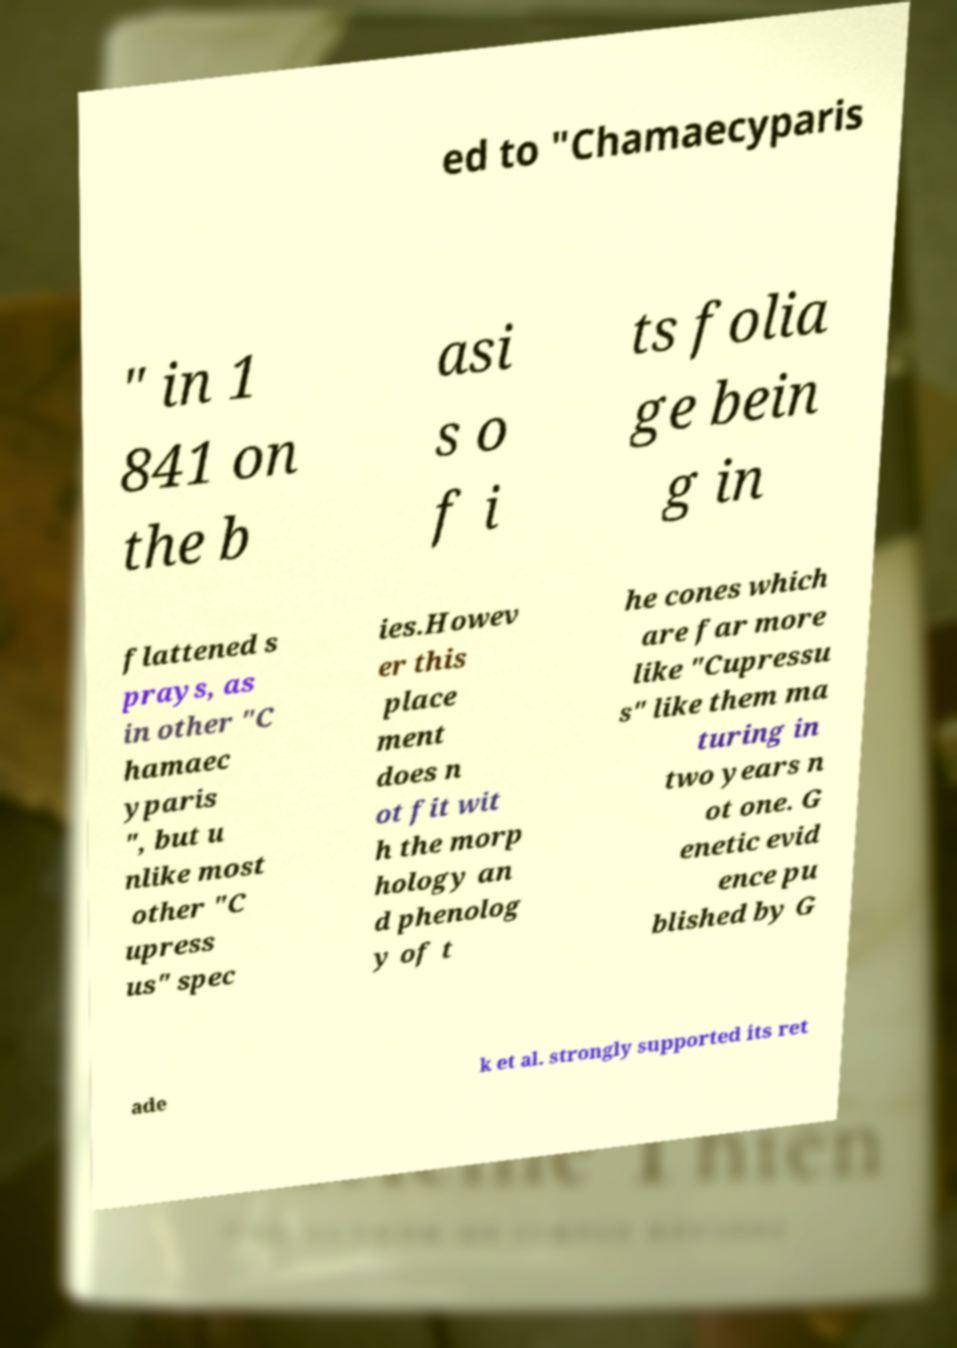I need the written content from this picture converted into text. Can you do that? ed to "Chamaecyparis " in 1 841 on the b asi s o f i ts folia ge bein g in flattened s prays, as in other "C hamaec yparis ", but u nlike most other "C upress us" spec ies.Howev er this place ment does n ot fit wit h the morp hology an d phenolog y of t he cones which are far more like "Cupressu s" like them ma turing in two years n ot one. G enetic evid ence pu blished by G ade k et al. strongly supported its ret 